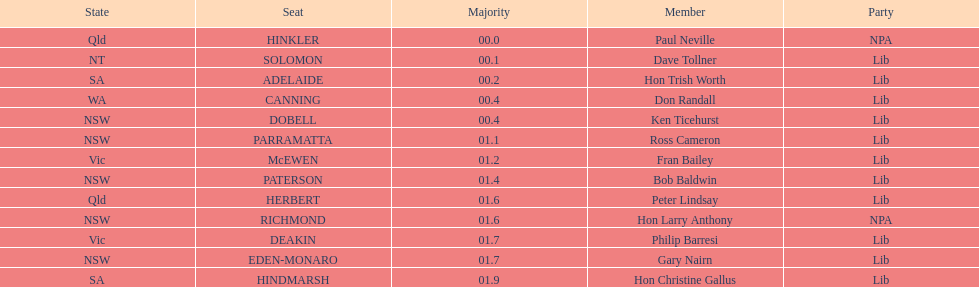Was fran bailey from vic or wa? Vic. 